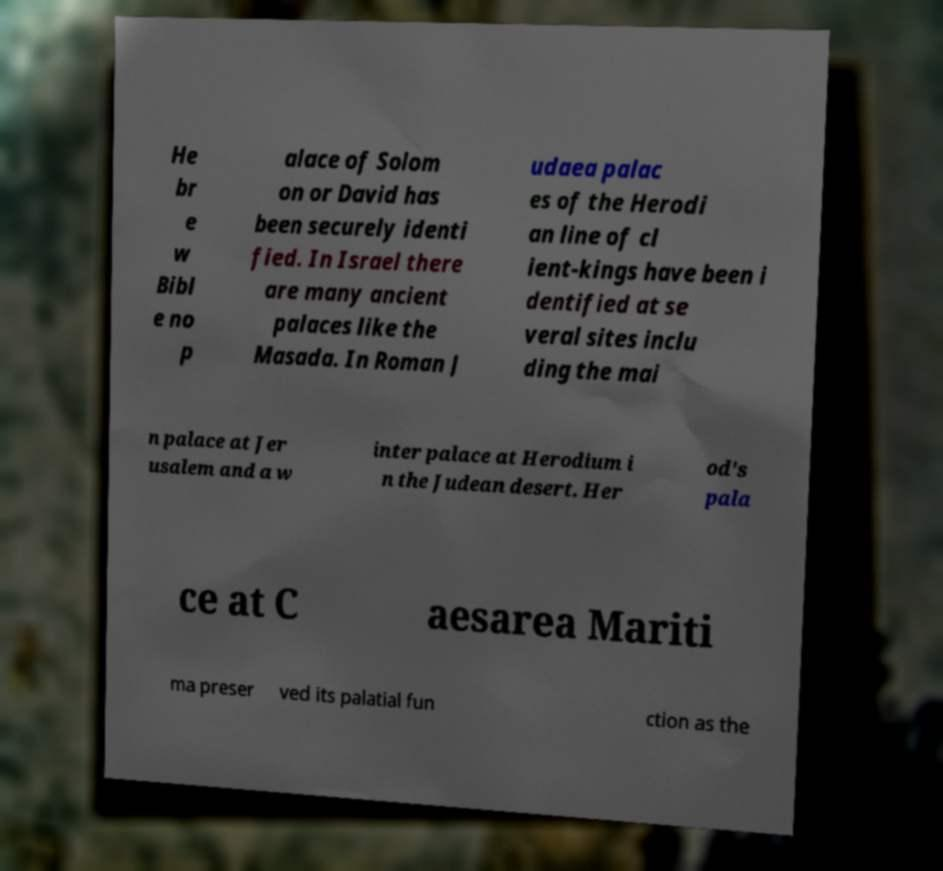For documentation purposes, I need the text within this image transcribed. Could you provide that? He br e w Bibl e no p alace of Solom on or David has been securely identi fied. In Israel there are many ancient palaces like the Masada. In Roman J udaea palac es of the Herodi an line of cl ient-kings have been i dentified at se veral sites inclu ding the mai n palace at Jer usalem and a w inter palace at Herodium i n the Judean desert. Her od's pala ce at C aesarea Mariti ma preser ved its palatial fun ction as the 